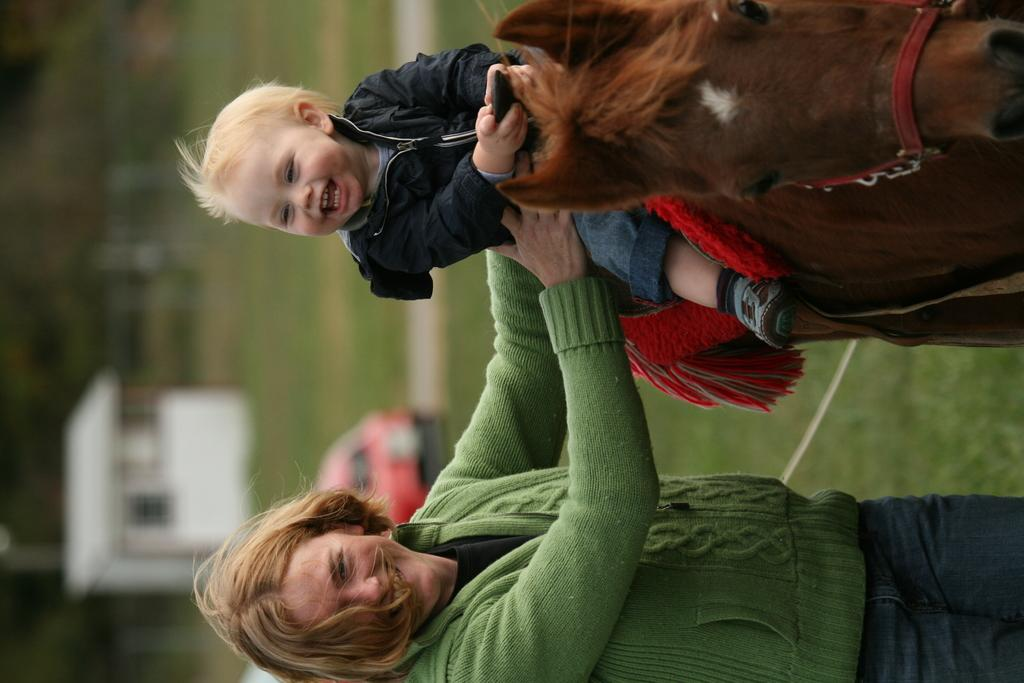Who are the people in the foreground of the image? There is a woman and a boy in the foreground of the image. What is the boy doing in the image? The boy is sitting on a horse. What can be seen in the background of the image? There is a house, a fence, trees, grass, and an unspecified object in the background of the image. What type of basketball game is being played in the background of the image? There is no basketball game present in the image; it features a woman, a boy on a horse, and various background elements. What discovery was made by the stick-wielding explorers in the image? There are no stick-wielding explorers or any discoveries mentioned in the image. 